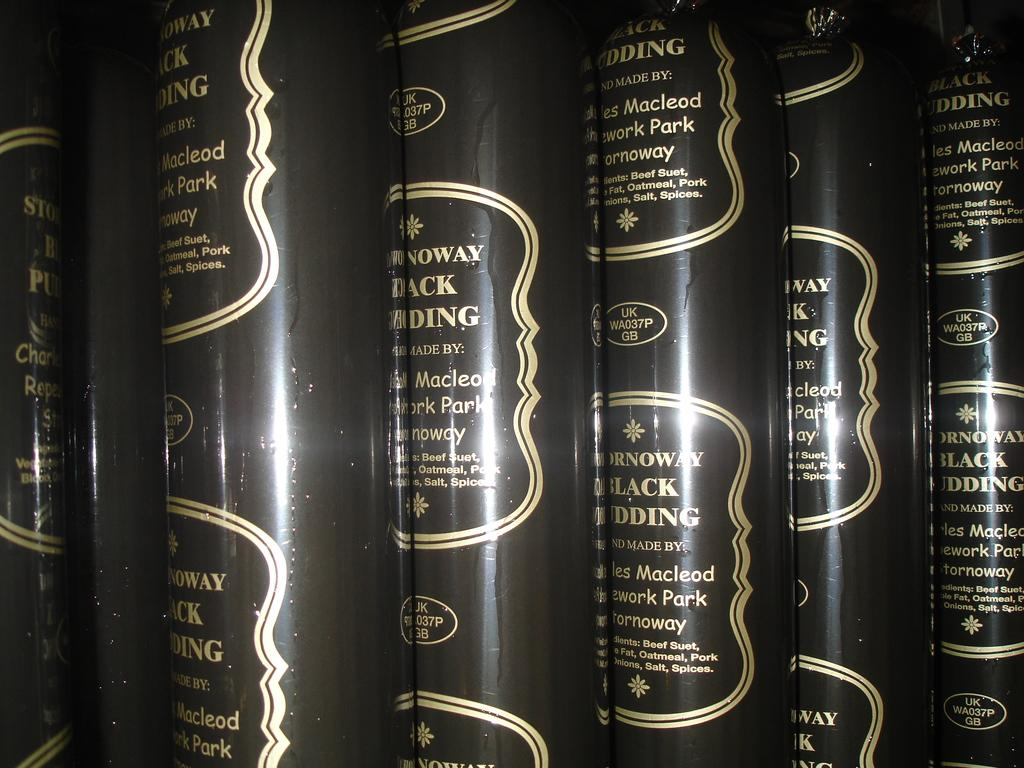<image>
Render a clear and concise summary of the photo. A group of black covers or cases that have contents made by somebody with the name Macleod. 